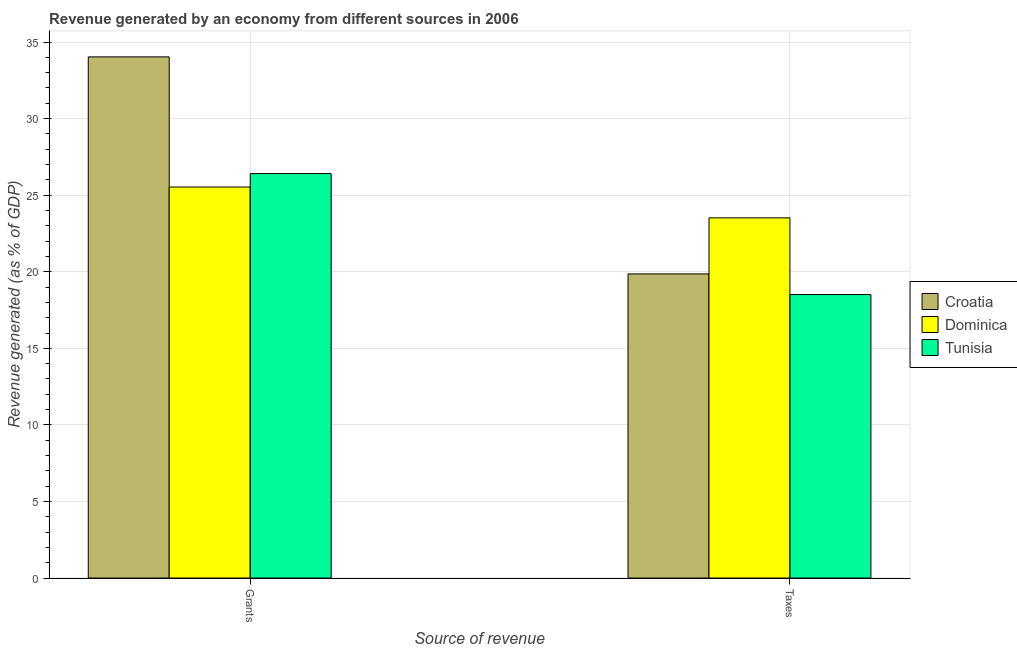How many groups of bars are there?
Your response must be concise. 2. Are the number of bars on each tick of the X-axis equal?
Your answer should be very brief. Yes. How many bars are there on the 1st tick from the left?
Ensure brevity in your answer.  3. What is the label of the 1st group of bars from the left?
Provide a succinct answer. Grants. What is the revenue generated by grants in Croatia?
Give a very brief answer. 34.03. Across all countries, what is the maximum revenue generated by taxes?
Offer a very short reply. 23.52. Across all countries, what is the minimum revenue generated by taxes?
Your response must be concise. 18.51. In which country was the revenue generated by grants maximum?
Provide a short and direct response. Croatia. In which country was the revenue generated by taxes minimum?
Provide a succinct answer. Tunisia. What is the total revenue generated by taxes in the graph?
Give a very brief answer. 61.89. What is the difference between the revenue generated by grants in Croatia and that in Tunisia?
Give a very brief answer. 7.62. What is the difference between the revenue generated by grants in Croatia and the revenue generated by taxes in Dominica?
Your answer should be compact. 10.51. What is the average revenue generated by taxes per country?
Your answer should be very brief. 20.63. What is the difference between the revenue generated by grants and revenue generated by taxes in Dominica?
Your answer should be very brief. 2.01. In how many countries, is the revenue generated by grants greater than 20 %?
Provide a succinct answer. 3. What is the ratio of the revenue generated by grants in Tunisia to that in Croatia?
Your answer should be compact. 0.78. Is the revenue generated by grants in Dominica less than that in Croatia?
Your answer should be very brief. Yes. In how many countries, is the revenue generated by taxes greater than the average revenue generated by taxes taken over all countries?
Make the answer very short. 1. What does the 2nd bar from the left in Grants represents?
Make the answer very short. Dominica. What does the 2nd bar from the right in Taxes represents?
Offer a terse response. Dominica. Are all the bars in the graph horizontal?
Ensure brevity in your answer.  No. Does the graph contain any zero values?
Offer a very short reply. No. What is the title of the graph?
Make the answer very short. Revenue generated by an economy from different sources in 2006. What is the label or title of the X-axis?
Give a very brief answer. Source of revenue. What is the label or title of the Y-axis?
Your answer should be very brief. Revenue generated (as % of GDP). What is the Revenue generated (as % of GDP) of Croatia in Grants?
Offer a very short reply. 34.03. What is the Revenue generated (as % of GDP) of Dominica in Grants?
Provide a short and direct response. 25.53. What is the Revenue generated (as % of GDP) of Tunisia in Grants?
Offer a terse response. 26.41. What is the Revenue generated (as % of GDP) of Croatia in Taxes?
Your response must be concise. 19.86. What is the Revenue generated (as % of GDP) of Dominica in Taxes?
Keep it short and to the point. 23.52. What is the Revenue generated (as % of GDP) in Tunisia in Taxes?
Offer a very short reply. 18.51. Across all Source of revenue, what is the maximum Revenue generated (as % of GDP) of Croatia?
Make the answer very short. 34.03. Across all Source of revenue, what is the maximum Revenue generated (as % of GDP) of Dominica?
Give a very brief answer. 25.53. Across all Source of revenue, what is the maximum Revenue generated (as % of GDP) of Tunisia?
Your answer should be compact. 26.41. Across all Source of revenue, what is the minimum Revenue generated (as % of GDP) of Croatia?
Provide a short and direct response. 19.86. Across all Source of revenue, what is the minimum Revenue generated (as % of GDP) of Dominica?
Ensure brevity in your answer.  23.52. Across all Source of revenue, what is the minimum Revenue generated (as % of GDP) of Tunisia?
Provide a succinct answer. 18.51. What is the total Revenue generated (as % of GDP) of Croatia in the graph?
Your answer should be very brief. 53.89. What is the total Revenue generated (as % of GDP) in Dominica in the graph?
Provide a succinct answer. 49.05. What is the total Revenue generated (as % of GDP) of Tunisia in the graph?
Offer a very short reply. 44.92. What is the difference between the Revenue generated (as % of GDP) of Croatia in Grants and that in Taxes?
Offer a very short reply. 14.17. What is the difference between the Revenue generated (as % of GDP) of Dominica in Grants and that in Taxes?
Make the answer very short. 2.01. What is the difference between the Revenue generated (as % of GDP) of Tunisia in Grants and that in Taxes?
Offer a terse response. 7.9. What is the difference between the Revenue generated (as % of GDP) in Croatia in Grants and the Revenue generated (as % of GDP) in Dominica in Taxes?
Provide a short and direct response. 10.51. What is the difference between the Revenue generated (as % of GDP) in Croatia in Grants and the Revenue generated (as % of GDP) in Tunisia in Taxes?
Your response must be concise. 15.52. What is the difference between the Revenue generated (as % of GDP) in Dominica in Grants and the Revenue generated (as % of GDP) in Tunisia in Taxes?
Provide a succinct answer. 7.02. What is the average Revenue generated (as % of GDP) of Croatia per Source of revenue?
Keep it short and to the point. 26.94. What is the average Revenue generated (as % of GDP) in Dominica per Source of revenue?
Make the answer very short. 24.53. What is the average Revenue generated (as % of GDP) in Tunisia per Source of revenue?
Ensure brevity in your answer.  22.46. What is the difference between the Revenue generated (as % of GDP) of Croatia and Revenue generated (as % of GDP) of Dominica in Grants?
Give a very brief answer. 8.5. What is the difference between the Revenue generated (as % of GDP) of Croatia and Revenue generated (as % of GDP) of Tunisia in Grants?
Ensure brevity in your answer.  7.62. What is the difference between the Revenue generated (as % of GDP) in Dominica and Revenue generated (as % of GDP) in Tunisia in Grants?
Offer a very short reply. -0.88. What is the difference between the Revenue generated (as % of GDP) in Croatia and Revenue generated (as % of GDP) in Dominica in Taxes?
Offer a very short reply. -3.66. What is the difference between the Revenue generated (as % of GDP) in Croatia and Revenue generated (as % of GDP) in Tunisia in Taxes?
Your answer should be compact. 1.35. What is the difference between the Revenue generated (as % of GDP) in Dominica and Revenue generated (as % of GDP) in Tunisia in Taxes?
Ensure brevity in your answer.  5.01. What is the ratio of the Revenue generated (as % of GDP) in Croatia in Grants to that in Taxes?
Make the answer very short. 1.71. What is the ratio of the Revenue generated (as % of GDP) in Dominica in Grants to that in Taxes?
Offer a very short reply. 1.09. What is the ratio of the Revenue generated (as % of GDP) in Tunisia in Grants to that in Taxes?
Provide a short and direct response. 1.43. What is the difference between the highest and the second highest Revenue generated (as % of GDP) in Croatia?
Offer a very short reply. 14.17. What is the difference between the highest and the second highest Revenue generated (as % of GDP) in Dominica?
Make the answer very short. 2.01. What is the difference between the highest and the second highest Revenue generated (as % of GDP) in Tunisia?
Provide a short and direct response. 7.9. What is the difference between the highest and the lowest Revenue generated (as % of GDP) in Croatia?
Give a very brief answer. 14.17. What is the difference between the highest and the lowest Revenue generated (as % of GDP) of Dominica?
Your answer should be compact. 2.01. What is the difference between the highest and the lowest Revenue generated (as % of GDP) of Tunisia?
Keep it short and to the point. 7.9. 